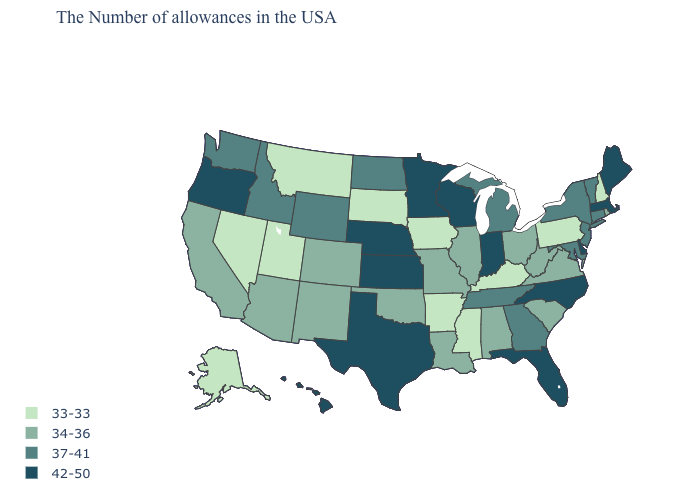Name the states that have a value in the range 37-41?
Give a very brief answer. Vermont, Connecticut, New York, New Jersey, Maryland, Georgia, Michigan, Tennessee, North Dakota, Wyoming, Idaho, Washington. What is the value of South Dakota?
Be succinct. 33-33. What is the value of Louisiana?
Answer briefly. 34-36. How many symbols are there in the legend?
Keep it brief. 4. Name the states that have a value in the range 34-36?
Concise answer only. Rhode Island, Virginia, South Carolina, West Virginia, Ohio, Alabama, Illinois, Louisiana, Missouri, Oklahoma, Colorado, New Mexico, Arizona, California. Does Hawaii have the highest value in the USA?
Short answer required. Yes. Name the states that have a value in the range 37-41?
Quick response, please. Vermont, Connecticut, New York, New Jersey, Maryland, Georgia, Michigan, Tennessee, North Dakota, Wyoming, Idaho, Washington. What is the highest value in the USA?
Quick response, please. 42-50. What is the highest value in states that border Virginia?
Give a very brief answer. 42-50. Name the states that have a value in the range 42-50?
Be succinct. Maine, Massachusetts, Delaware, North Carolina, Florida, Indiana, Wisconsin, Minnesota, Kansas, Nebraska, Texas, Oregon, Hawaii. Does Pennsylvania have the same value as Oregon?
Quick response, please. No. What is the value of South Dakota?
Short answer required. 33-33. How many symbols are there in the legend?
Keep it brief. 4. Among the states that border Nevada , which have the lowest value?
Be succinct. Utah. What is the lowest value in the USA?
Give a very brief answer. 33-33. 